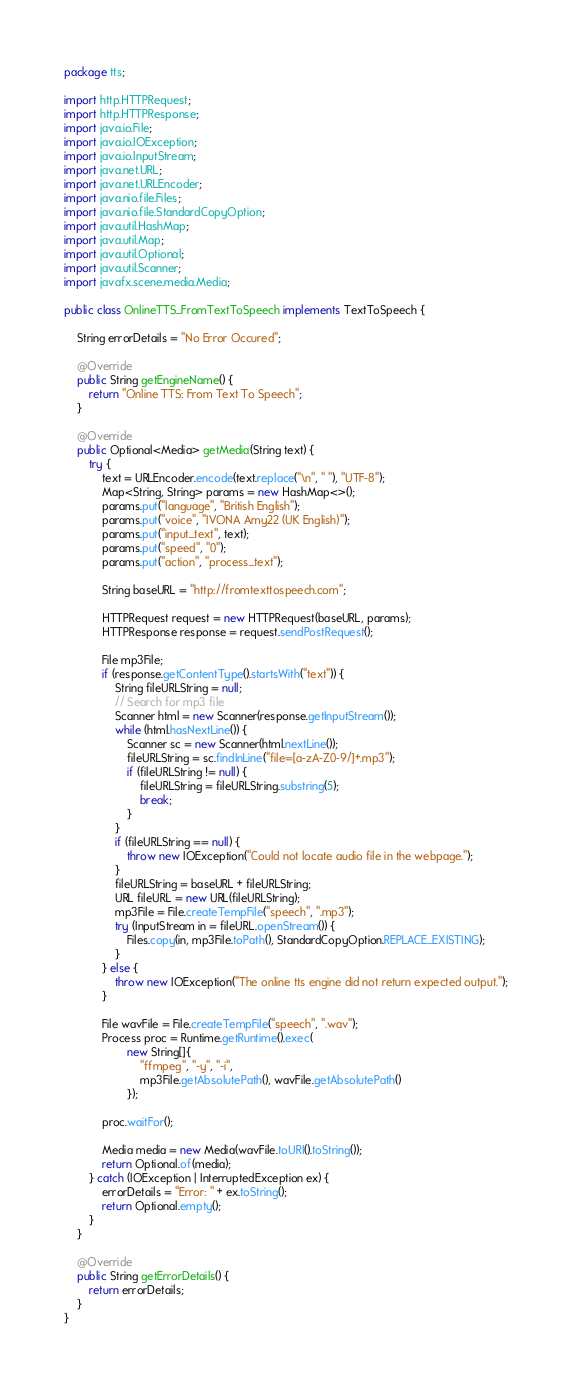<code> <loc_0><loc_0><loc_500><loc_500><_Java_>package tts;

import http.HTTPRequest;
import http.HTTPResponse;
import java.io.File;
import java.io.IOException;
import java.io.InputStream;
import java.net.URL;
import java.net.URLEncoder;
import java.nio.file.Files;
import java.nio.file.StandardCopyOption;
import java.util.HashMap;
import java.util.Map;
import java.util.Optional;
import java.util.Scanner;
import javafx.scene.media.Media;

public class OnlineTTS_FromTextToSpeech implements TextToSpeech {

    String errorDetails = "No Error Occured";

    @Override
    public String getEngineName() {
        return "Online TTS: From Text To Speech";
    }

    @Override
    public Optional<Media> getMedia(String text) {
        try {
            text = URLEncoder.encode(text.replace("\n", " "), "UTF-8");
            Map<String, String> params = new HashMap<>();
            params.put("language", "British English");
            params.put("voice", "IVONA Amy22 (UK English)");
            params.put("input_text", text);
            params.put("speed", "0");
            params.put("action", "process_text");

            String baseURL = "http://fromtexttospeech.com";

            HTTPRequest request = new HTTPRequest(baseURL, params);
            HTTPResponse response = request.sendPostRequest();

            File mp3File;
            if (response.getContentType().startsWith("text")) {
                String fileURLString = null;
                // Search for mp3 file
                Scanner html = new Scanner(response.getInputStream());
                while (html.hasNextLine()) {
                    Scanner sc = new Scanner(html.nextLine());
                    fileURLString = sc.findInLine("file=[a-zA-Z0-9/]+.mp3");
                    if (fileURLString != null) {
                        fileURLString = fileURLString.substring(5);
                        break;
                    }
                }
                if (fileURLString == null) {
                    throw new IOException("Could not locate audio file in the webpage.");
                }
                fileURLString = baseURL + fileURLString;
                URL fileURL = new URL(fileURLString);
                mp3File = File.createTempFile("speech", ".mp3");
                try (InputStream in = fileURL.openStream()) {
                    Files.copy(in, mp3File.toPath(), StandardCopyOption.REPLACE_EXISTING);
                }
            } else {
                throw new IOException("The online tts engine did not return expected output.");
            }

            File wavFile = File.createTempFile("speech", ".wav");
            Process proc = Runtime.getRuntime().exec(
                    new String[]{
                        "ffmpeg", "-y", "-i",
                        mp3File.getAbsolutePath(), wavFile.getAbsolutePath()
                    });

            proc.waitFor();

            Media media = new Media(wavFile.toURI().toString());
            return Optional.of(media);
        } catch (IOException | InterruptedException ex) {
            errorDetails = "Error: " + ex.toString();
            return Optional.empty();
        }
    }

    @Override
    public String getErrorDetails() {
        return errorDetails;
    }
}
</code> 